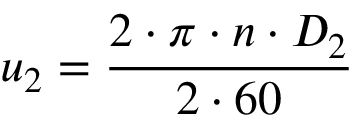Convert formula to latex. <formula><loc_0><loc_0><loc_500><loc_500>u _ { 2 } = \frac { 2 \cdot \pi \cdot n \cdot D _ { 2 } } { 2 \cdot 6 0 }</formula> 